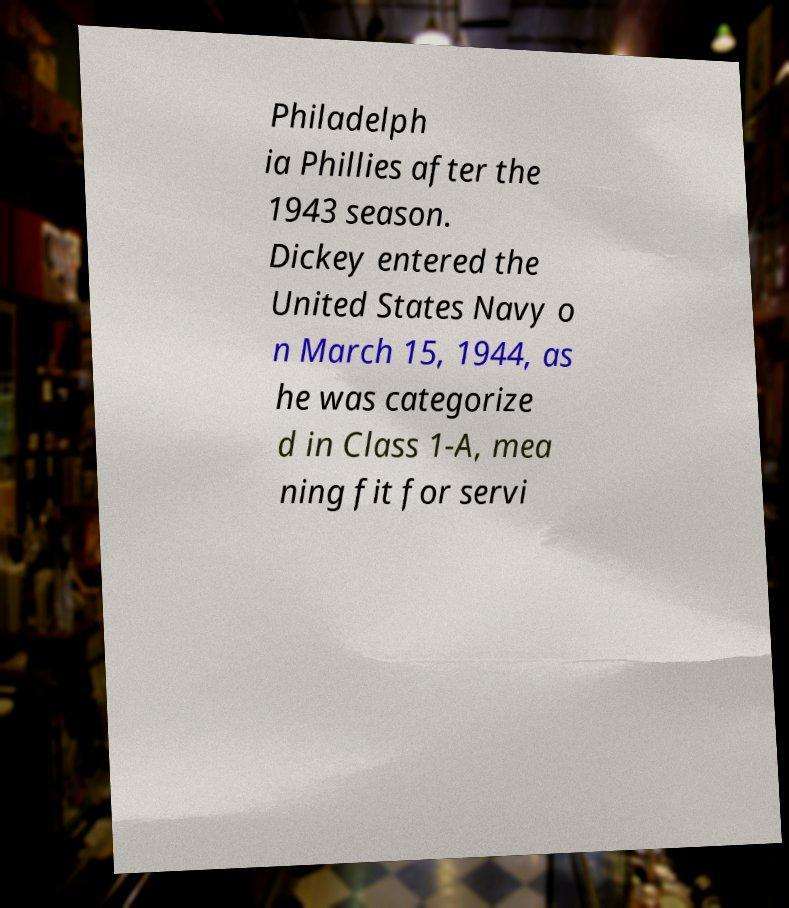There's text embedded in this image that I need extracted. Can you transcribe it verbatim? Philadelph ia Phillies after the 1943 season. Dickey entered the United States Navy o n March 15, 1944, as he was categorize d in Class 1-A, mea ning fit for servi 